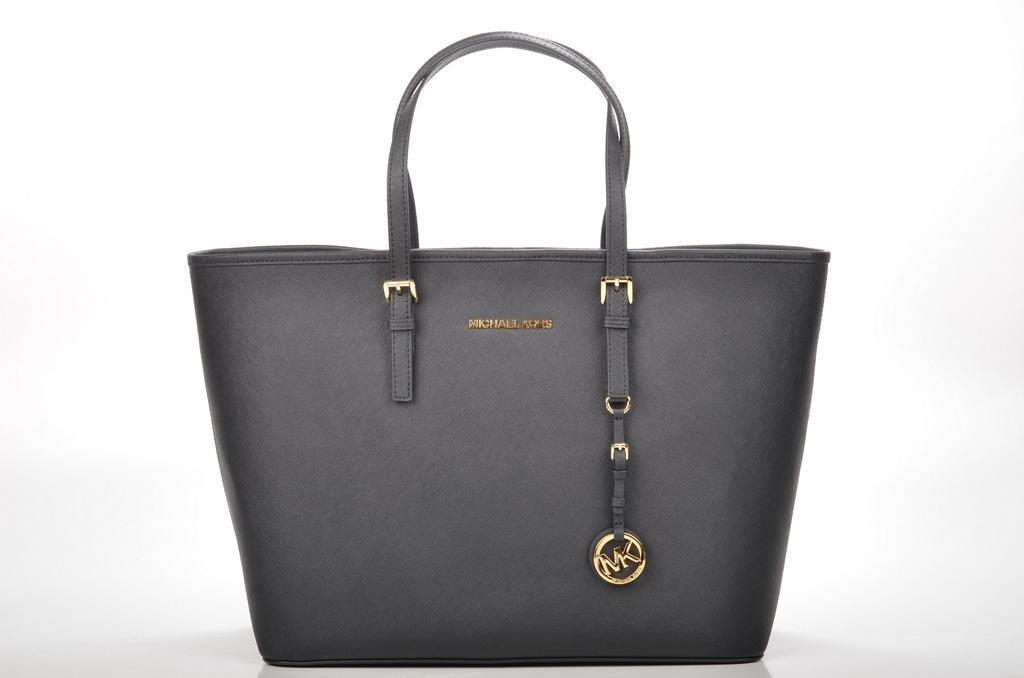Can you describe this image briefly? In this picture, here we can see a grey colored handbag and the at the bottom, we can see a mark labelled as MK which is the brand name of the bag. It seems like Michael Kiss in which layer word is not clearly visible. 